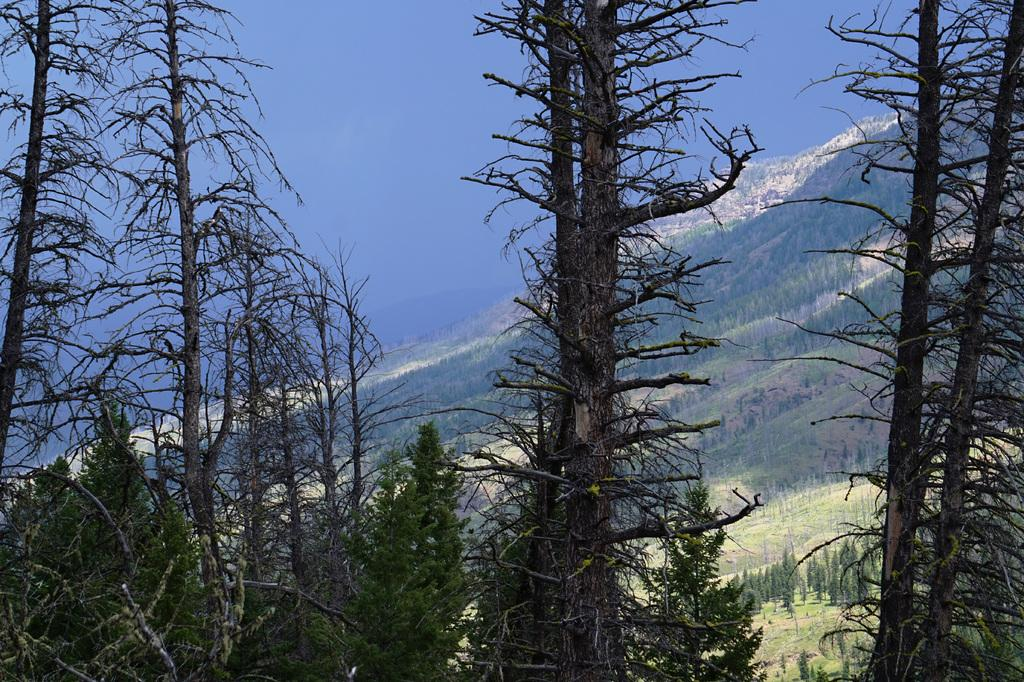What type of natural elements can be seen in the image? There are trees in the image. What type of landscape feature is visible in the background? There are mountains in the background of the image. What else can be seen in the background of the image? The sky is visible in the background of the image. Is there a spy observing the trees in the image? There is no indication of a spy or any human presence in the image; it only features trees, mountains, and the sky. 